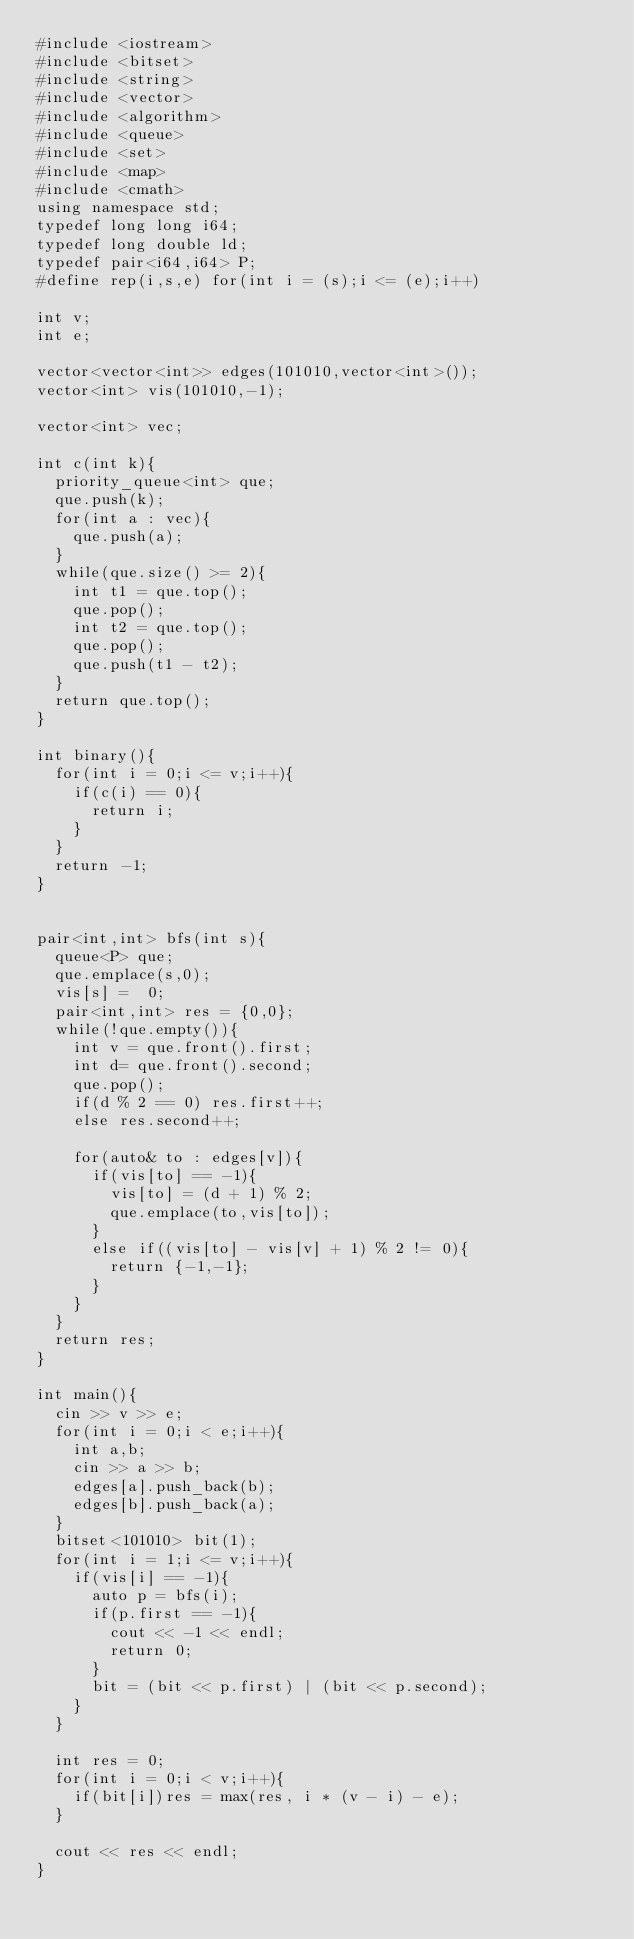Convert code to text. <code><loc_0><loc_0><loc_500><loc_500><_C++_>#include <iostream>
#include <bitset>
#include <string>
#include <vector>
#include <algorithm>
#include <queue>
#include <set>
#include <map>
#include <cmath>
using namespace std;
typedef long long i64;
typedef long double ld;
typedef pair<i64,i64> P;
#define rep(i,s,e) for(int i = (s);i <= (e);i++)

int v;
int e;

vector<vector<int>> edges(101010,vector<int>());
vector<int> vis(101010,-1);

vector<int> vec;

int c(int k){
	priority_queue<int> que;
	que.push(k);
	for(int a : vec){
		que.push(a);
	}
	while(que.size() >= 2){
		int t1 = que.top();
		que.pop();
		int t2 = que.top();
		que.pop();
		que.push(t1 - t2);
	}
	return que.top();
}

int binary(){
	for(int i = 0;i <= v;i++){
		if(c(i) == 0){
			return i;
		}
	}
	return -1;
}


pair<int,int> bfs(int s){
	queue<P> que;
	que.emplace(s,0);
	vis[s] =  0;
	pair<int,int> res = {0,0};
	while(!que.empty()){
		int v = que.front().first;
		int d= que.front().second;
		que.pop();
		if(d % 2 == 0) res.first++;
		else res.second++;

		for(auto& to : edges[v]){
			if(vis[to] == -1){
				vis[to] = (d + 1) % 2;
				que.emplace(to,vis[to]);
			}
			else if((vis[to] - vis[v] + 1) % 2 != 0){
				return {-1,-1};
			}
		}
	}
	return res;
}

int main(){
	cin >> v >> e;
	for(int i = 0;i < e;i++){
		int a,b;
		cin >> a >> b;
		edges[a].push_back(b);
		edges[b].push_back(a);
	}
	bitset<101010> bit(1);
	for(int i = 1;i <= v;i++){
		if(vis[i] == -1){
			auto p = bfs(i);
			if(p.first == -1){
				cout << -1 << endl;
				return 0;
			}
			bit = (bit << p.first) | (bit << p.second);
		}
	}

	int res = 0;
	for(int i = 0;i < v;i++){
		if(bit[i])res = max(res, i * (v - i) - e);
	}

	cout << res << endl;
}

</code> 